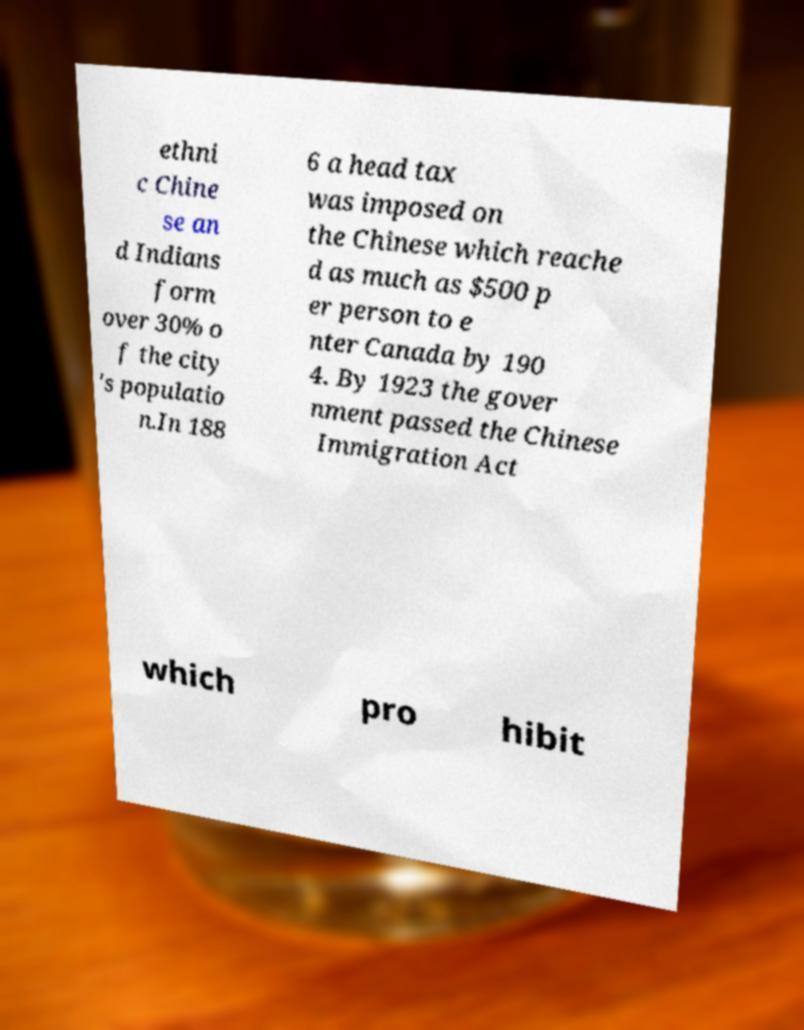I need the written content from this picture converted into text. Can you do that? ethni c Chine se an d Indians form over 30% o f the city 's populatio n.In 188 6 a head tax was imposed on the Chinese which reache d as much as $500 p er person to e nter Canada by 190 4. By 1923 the gover nment passed the Chinese Immigration Act which pro hibit 